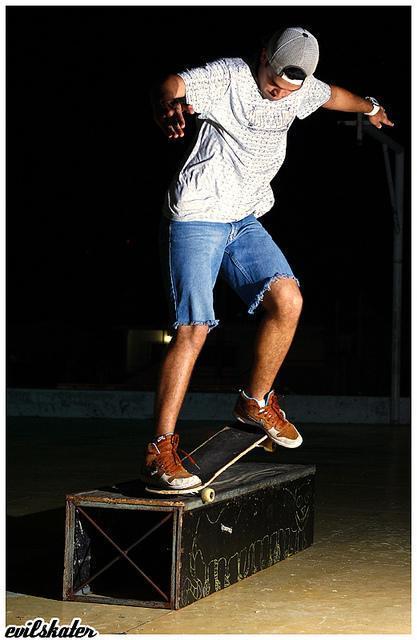How many people are there?
Give a very brief answer. 1. 